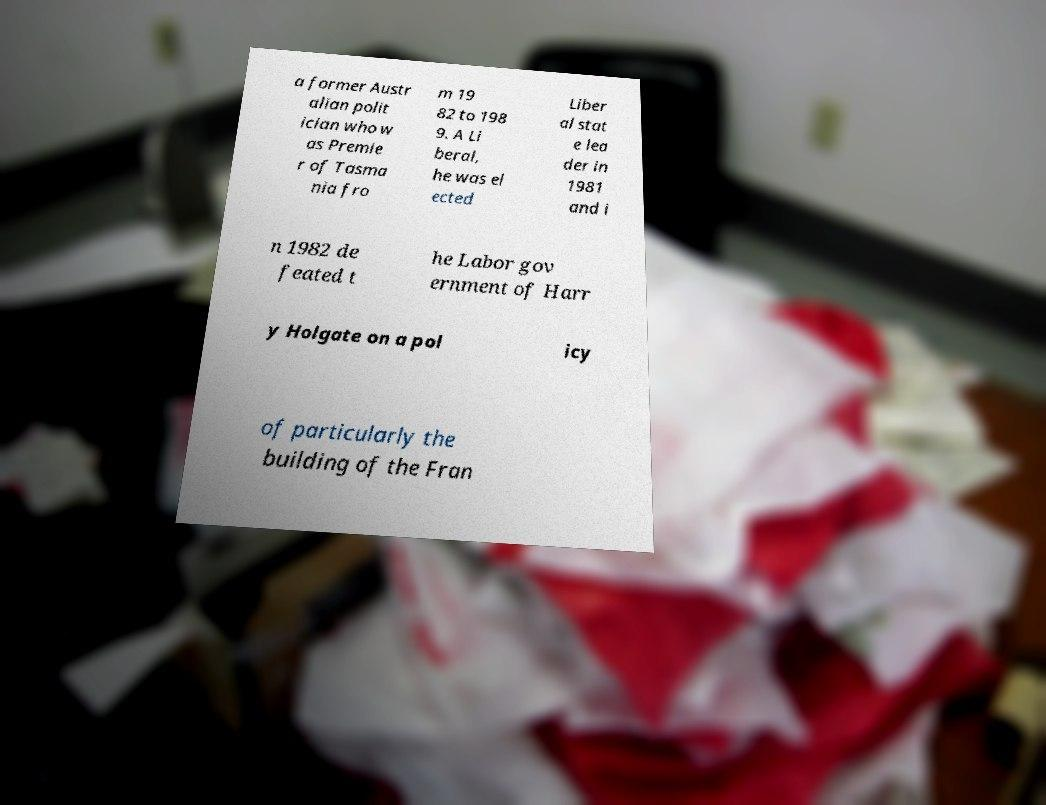I need the written content from this picture converted into text. Can you do that? a former Austr alian polit ician who w as Premie r of Tasma nia fro m 19 82 to 198 9. A Li beral, he was el ected Liber al stat e lea der in 1981 and i n 1982 de feated t he Labor gov ernment of Harr y Holgate on a pol icy of particularly the building of the Fran 